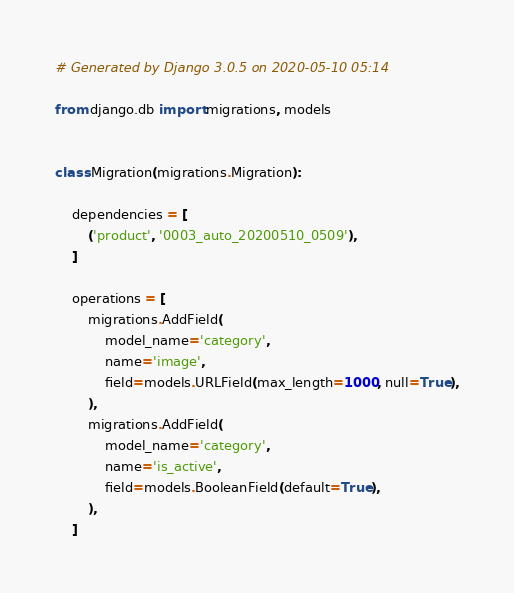Convert code to text. <code><loc_0><loc_0><loc_500><loc_500><_Python_># Generated by Django 3.0.5 on 2020-05-10 05:14

from django.db import migrations, models


class Migration(migrations.Migration):

    dependencies = [
        ('product', '0003_auto_20200510_0509'),
    ]

    operations = [
        migrations.AddField(
            model_name='category',
            name='image',
            field=models.URLField(max_length=1000, null=True),
        ),
        migrations.AddField(
            model_name='category',
            name='is_active',
            field=models.BooleanField(default=True),
        ),
    ]
</code> 